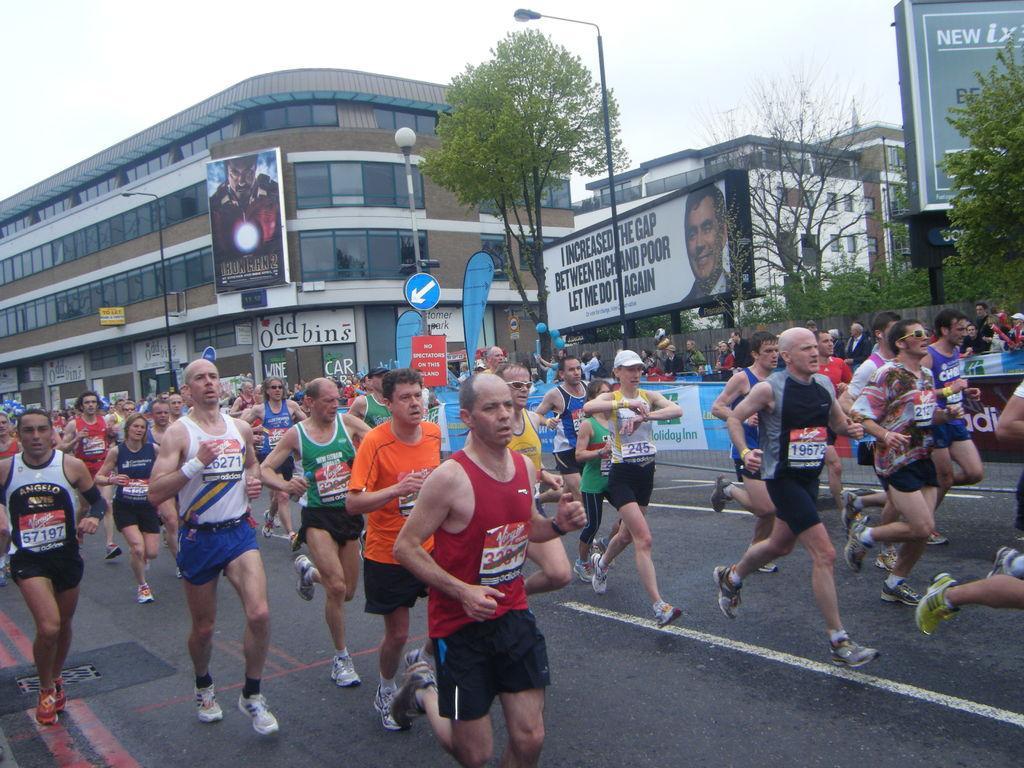Please provide a concise description of this image. This picture shows a few people running on the road and we see few buildings and couple of hoardings and few trees and few pole lights and a cloudy sky. We see a woman wore a cap on her head. 